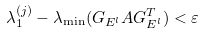Convert formula to latex. <formula><loc_0><loc_0><loc_500><loc_500>\lambda _ { 1 } ^ { ( j ) } - \lambda _ { \min } ( G _ { E ^ { l } } A G _ { E ^ { l } } ^ { T } ) < \varepsilon</formula> 